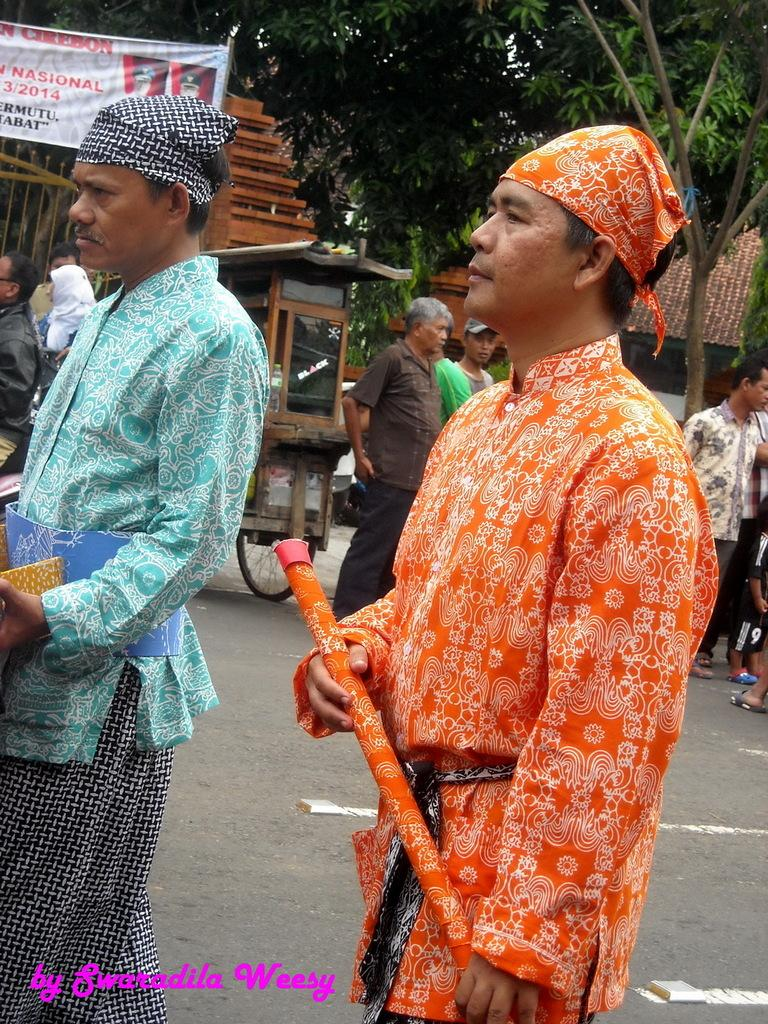How many people are in the image? There are two people in the image. What are the people holding in the image? The people are holding something, but the specific object is not mentioned in the facts. What type of headwear are the people wearing? The people have cloth on their heads. What else can be seen in the image besides the people? There is a poster and trees in the image. What type of control does the governor have over the trees in the image? There is no mention of a governor or control in the image, so this question cannot be answered definitively. 